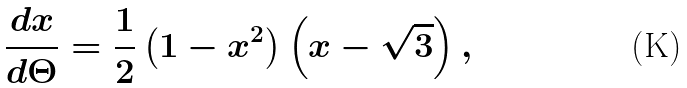<formula> <loc_0><loc_0><loc_500><loc_500>\frac { d x } { d \Theta } = \frac { 1 } { 2 } \left ( 1 - x ^ { 2 } \right ) \left ( x - \sqrt { 3 } \right ) ,</formula> 